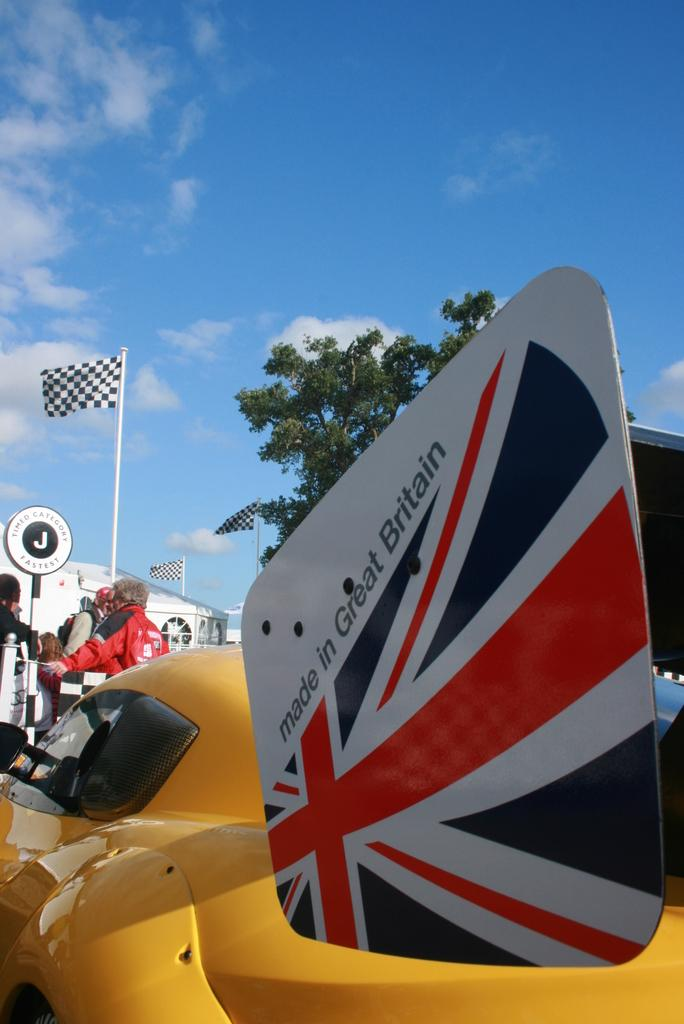Provide a one-sentence caption for the provided image. A yellow race car with a sign on it that says made in Great Britian. 